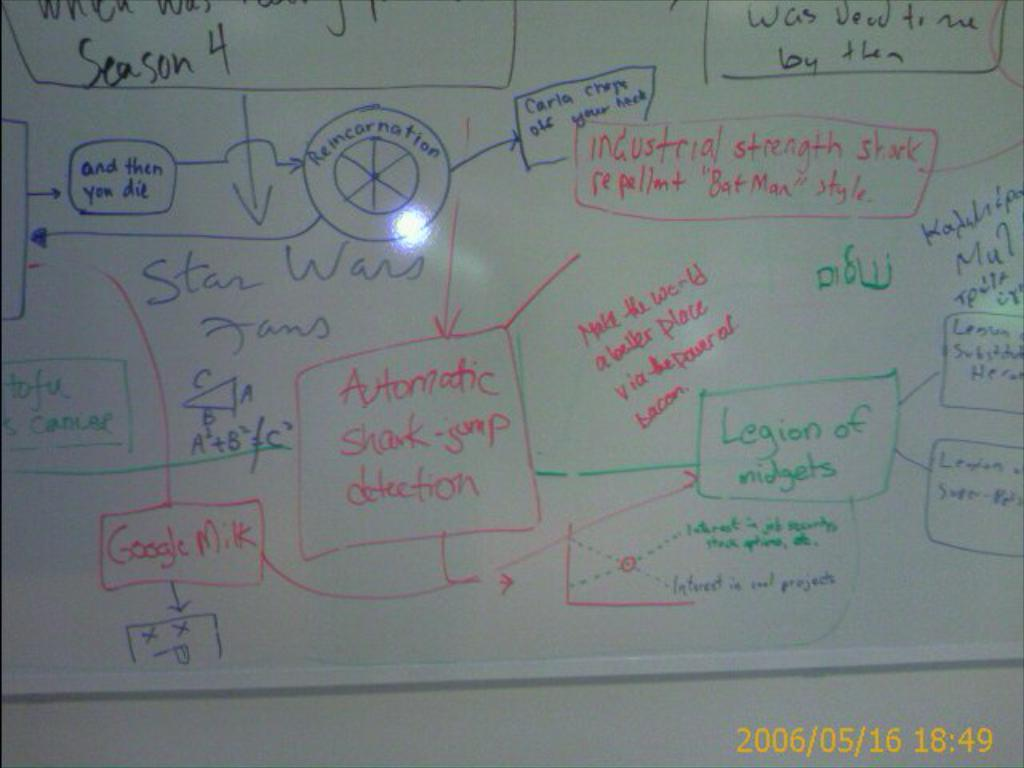Provide a one-sentence caption for the provided image. A white board has a flow chart wrote out on it that is about Star Wars fans. 